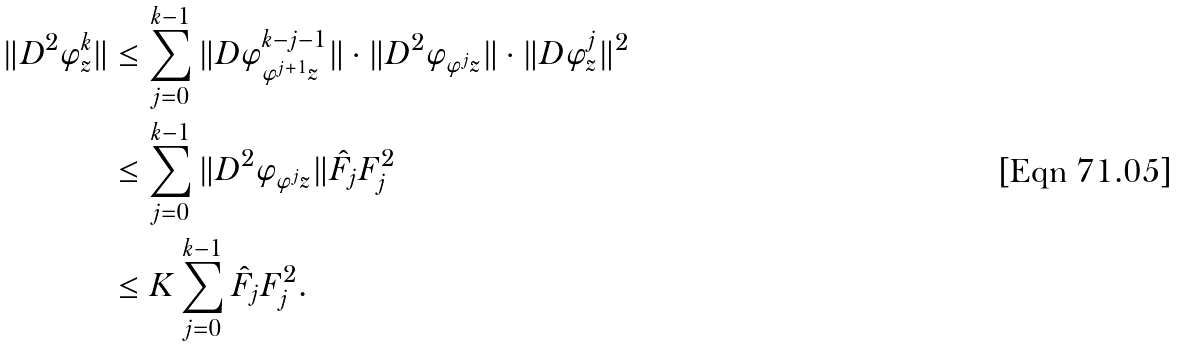<formula> <loc_0><loc_0><loc_500><loc_500>\| D ^ { 2 } \varphi ^ { k } _ { z } \| & \leq \sum _ { j = 0 } ^ { k - 1 } \| D \varphi ^ { k - j - 1 } _ { \varphi ^ { j + 1 } z } \| \cdot \| D ^ { 2 } \varphi _ { \varphi ^ { j } z } \| \cdot \| D \varphi ^ { j } _ { z } \| ^ { 2 } \\ & \leq \sum _ { j = 0 } ^ { k - 1 } \| D ^ { 2 } \varphi _ { \varphi ^ { j } z } \| \hat { F } _ { j } F _ { j } ^ { 2 } \\ & \leq K \sum _ { j = 0 } ^ { k - 1 } \hat { F } _ { j } F _ { j } ^ { 2 } .</formula> 